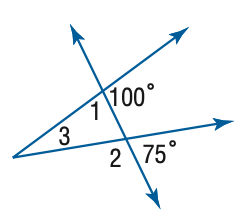Answer the mathemtical geometry problem and directly provide the correct option letter.
Question: Find the measure of \angle 2 in the figure.
Choices: A: 105 B: 110 C: 115 D: 120 A 